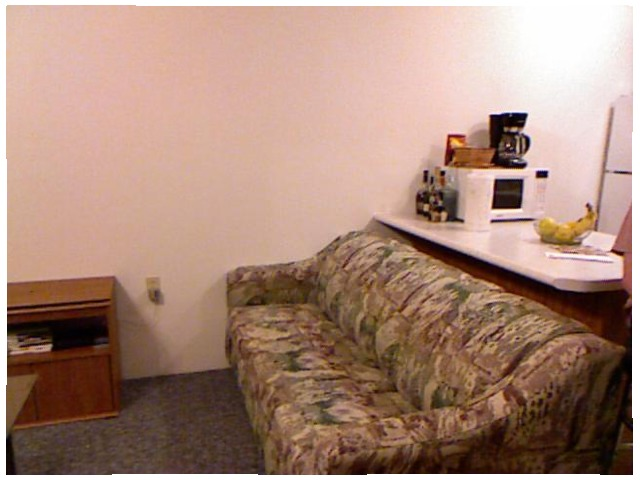<image>
Is the floor on the sofa? No. The floor is not positioned on the sofa. They may be near each other, but the floor is not supported by or resting on top of the sofa. Where is the microwave in relation to the couch? Is it behind the couch? Yes. From this viewpoint, the microwave is positioned behind the couch, with the couch partially or fully occluding the microwave. 